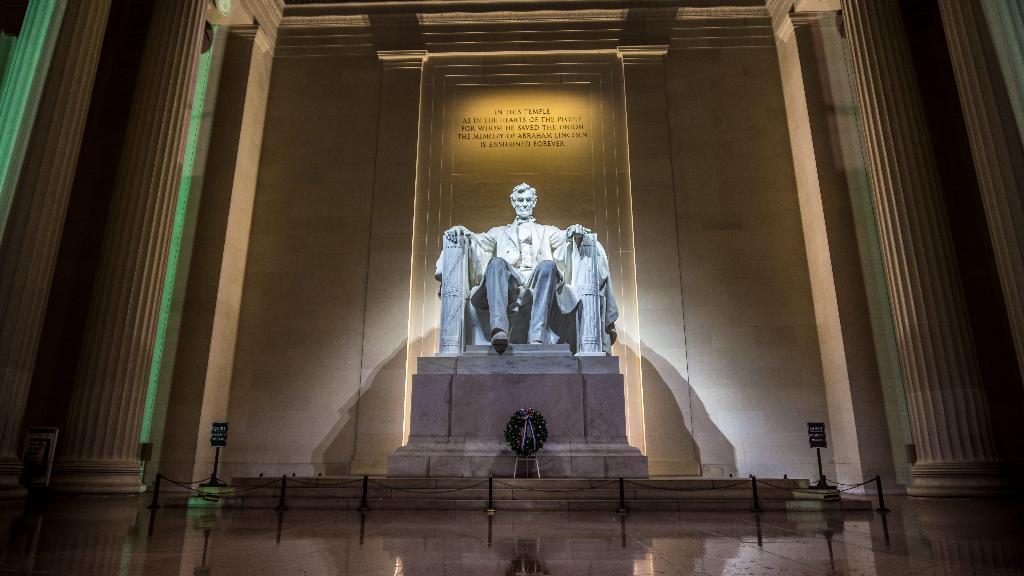In one or two sentences, can you explain what this image depicts? In the center of the picture there is a sculpture. On the right side there are pillars. On the left side there are pillars. In the center of the picture there is railing. At the top there is text on the stone. 